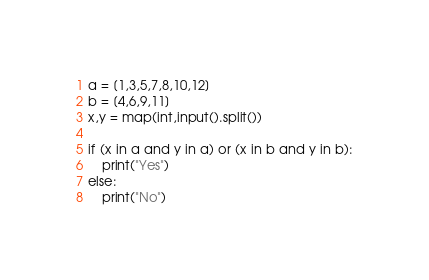Convert code to text. <code><loc_0><loc_0><loc_500><loc_500><_Python_>a = [1,3,5,7,8,10,12]
b = [4,6,9,11]
x,y = map(int,input().split())

if (x in a and y in a) or (x in b and y in b):
    print("Yes")
else:
    print("No")</code> 